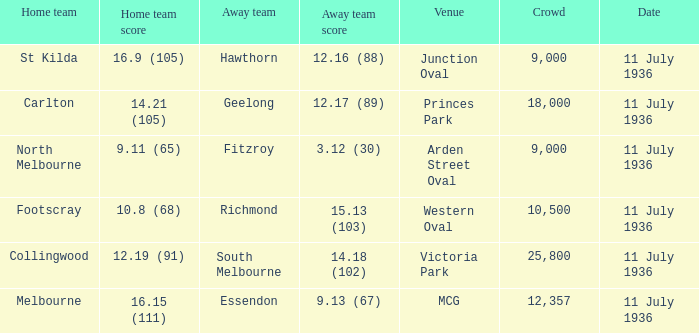Parse the table in full. {'header': ['Home team', 'Home team score', 'Away team', 'Away team score', 'Venue', 'Crowd', 'Date'], 'rows': [['St Kilda', '16.9 (105)', 'Hawthorn', '12.16 (88)', 'Junction Oval', '9,000', '11 July 1936'], ['Carlton', '14.21 (105)', 'Geelong', '12.17 (89)', 'Princes Park', '18,000', '11 July 1936'], ['North Melbourne', '9.11 (65)', 'Fitzroy', '3.12 (30)', 'Arden Street Oval', '9,000', '11 July 1936'], ['Footscray', '10.8 (68)', 'Richmond', '15.13 (103)', 'Western Oval', '10,500', '11 July 1936'], ['Collingwood', '12.19 (91)', 'South Melbourne', '14.18 (102)', 'Victoria Park', '25,800', '11 July 1936'], ['Melbourne', '16.15 (111)', 'Essendon', '9.13 (67)', 'MCG', '12,357', '11 July 1936']]} What Away team got a team score of 12.16 (88)? Hawthorn. 